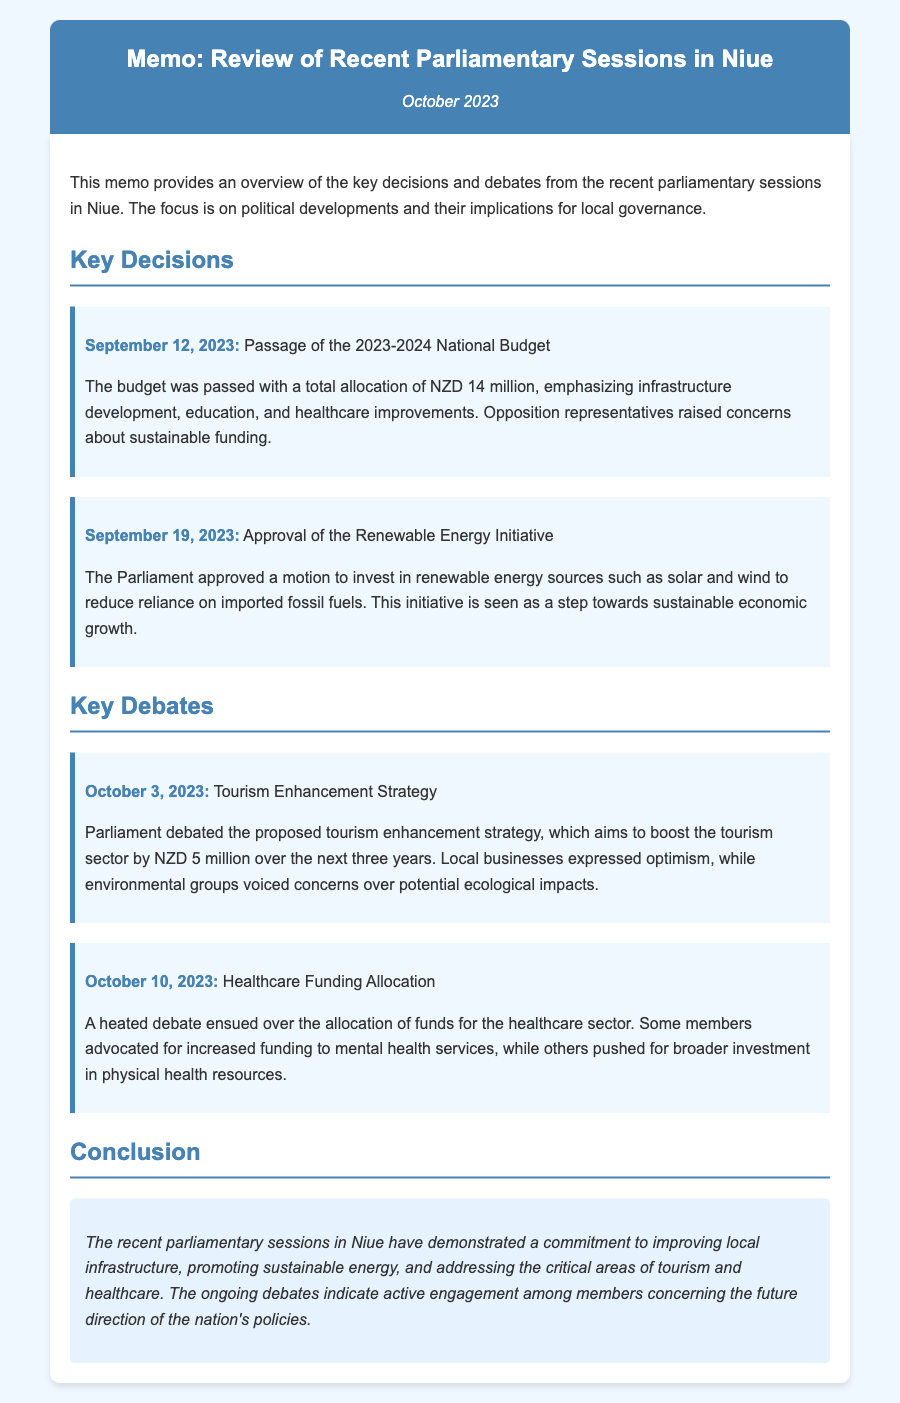What was the total allocation for the 2023-2024 National Budget? The total allocation for the budget is mentioned in the document as NZD 14 million.
Answer: NZD 14 million On what date was the Renewable Energy Initiative approved? The date of the approval of the Renewable Energy Initiative is specified in the document as September 19, 2023.
Answer: September 19, 2023 What amount was proposed for the tourism enhancement strategy? The proposed amount for the tourism enhancement strategy is included in the document as NZD 5 million.
Answer: NZD 5 million What two renewable energy sources are mentioned in the initiative? The initiative mentions two renewable energy sources which are solar and wind, as indicated in the document.
Answer: solar and wind What was a concern raised by opposition representatives regarding the budget? A concern mentioned in the document about the budget is related to sustainable funding.
Answer: sustainable funding What aspect of healthcare funding was emphasized during the debate on October 10, 2023? The debate emphasized mental health services in the healthcare funding allocation discussions as per the document.
Answer: mental health services Which two sectors were highlighted for improvement in the National Budget? The sectors identified for improvement in the National Budget are infrastructure development and education, as referenced in the document.
Answer: infrastructure development, education What was a key conclusion of the recent parliamentary sessions? The conclusion summarizes the commitment to improving local infrastructure as a key takeaway from the sessions, as stated in the document.
Answer: improving local infrastructure What date did the tourism enhancement strategy debate occur? The document specifies that the debate for the tourism enhancement strategy took place on October 3, 2023.
Answer: October 3, 2023 